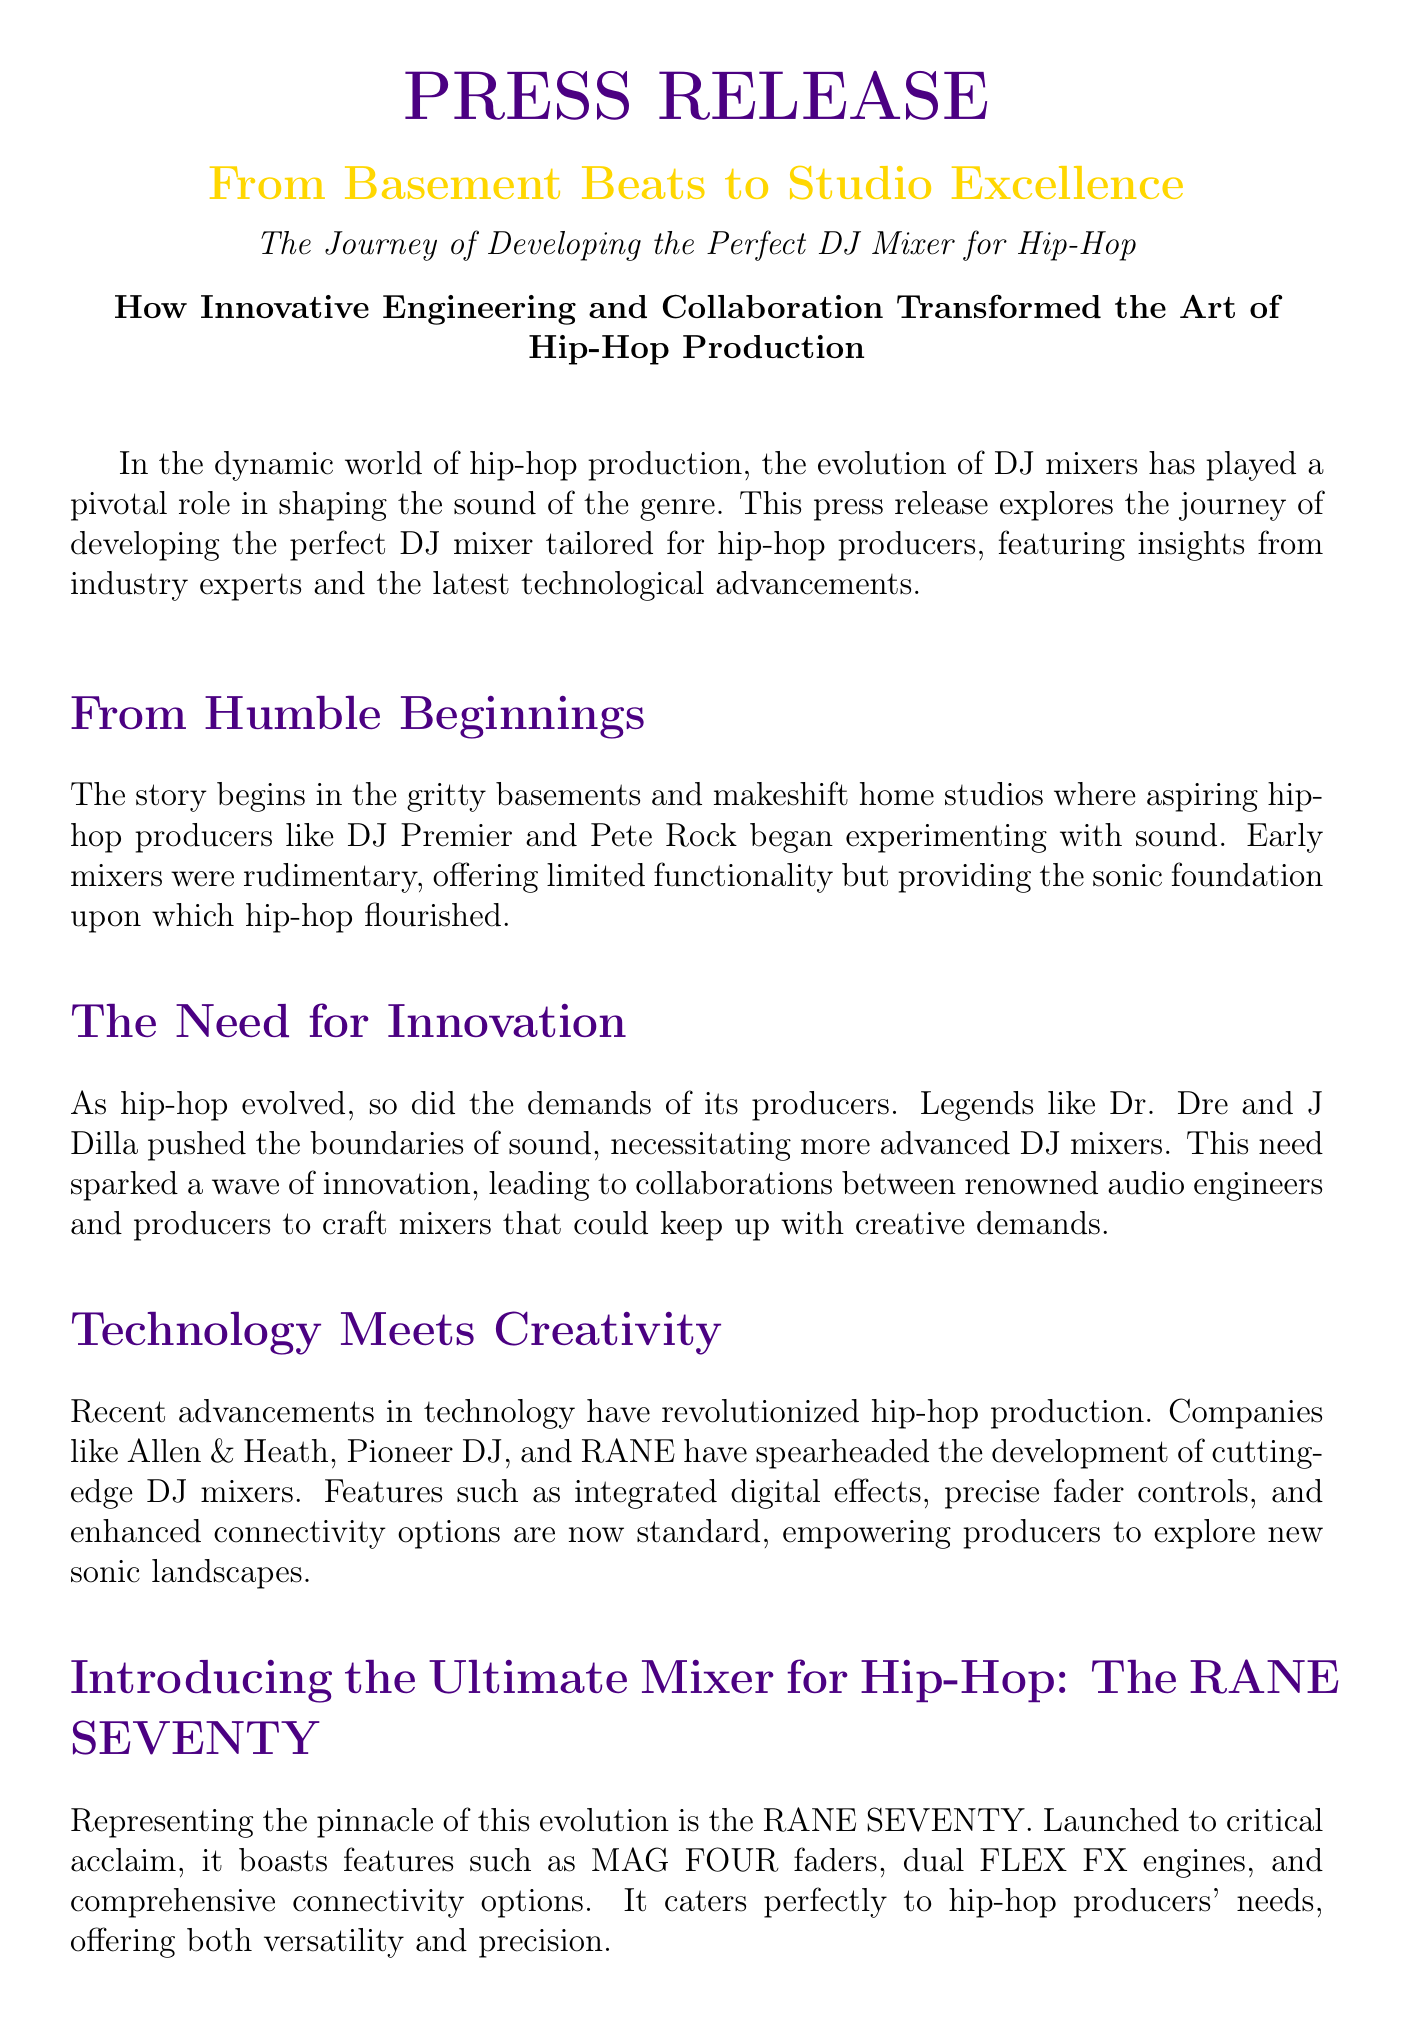What is the title of the press release? The title of the press release is clearly stated at the beginning of the document as "From Basement Beats to Studio Excellence."
Answer: From Basement Beats to Studio Excellence Who are some early hip-hop producers mentioned in the document? The press release mentions DJ Premier and Pete Rock as early hip-hop producers who began experimenting with sound.
Answer: DJ Premier and Pete Rock What mixer is introduced as the ultimate mixer for hip-hop? The document highlights the RANE SEVENTY as the ultimate mixer for hip-hop producers.
Answer: RANE SEVENTY What is one feature of the RANE SEVENTY? The document states that the RANE SEVENTY features MAG FOUR faders, dual FLEX FX engines, and comprehensive connectivity options.
Answer: MAG FOUR faders Which companies are noted for developing DJ mixers? The press release identifies Allen & Heath, Pioneer DJ, and RANE as companies that have developed advanced DJ mixers.
Answer: Allen & Heath, Pioneer DJ, RANE What role did innovation play in hip-hop production? The press release explains that innovation was necessary as the demands of hip-hop producers evolved, leading to technological advancements in DJ mixers.
Answer: Innovation was necessary How has technology impacted hip-hop production? The press release discusses that advancements in technology have revolutionized hip-hop production with features like integrated digital effects.
Answer: Revolutionized hip-hop production Which collaborative spirit is highlighted in the journey of developing the mixer? The press release emphasizes the synergy between producers and engineers in creating innovative tools for hip-hop production.
Answer: Synergy between producers and engineers 